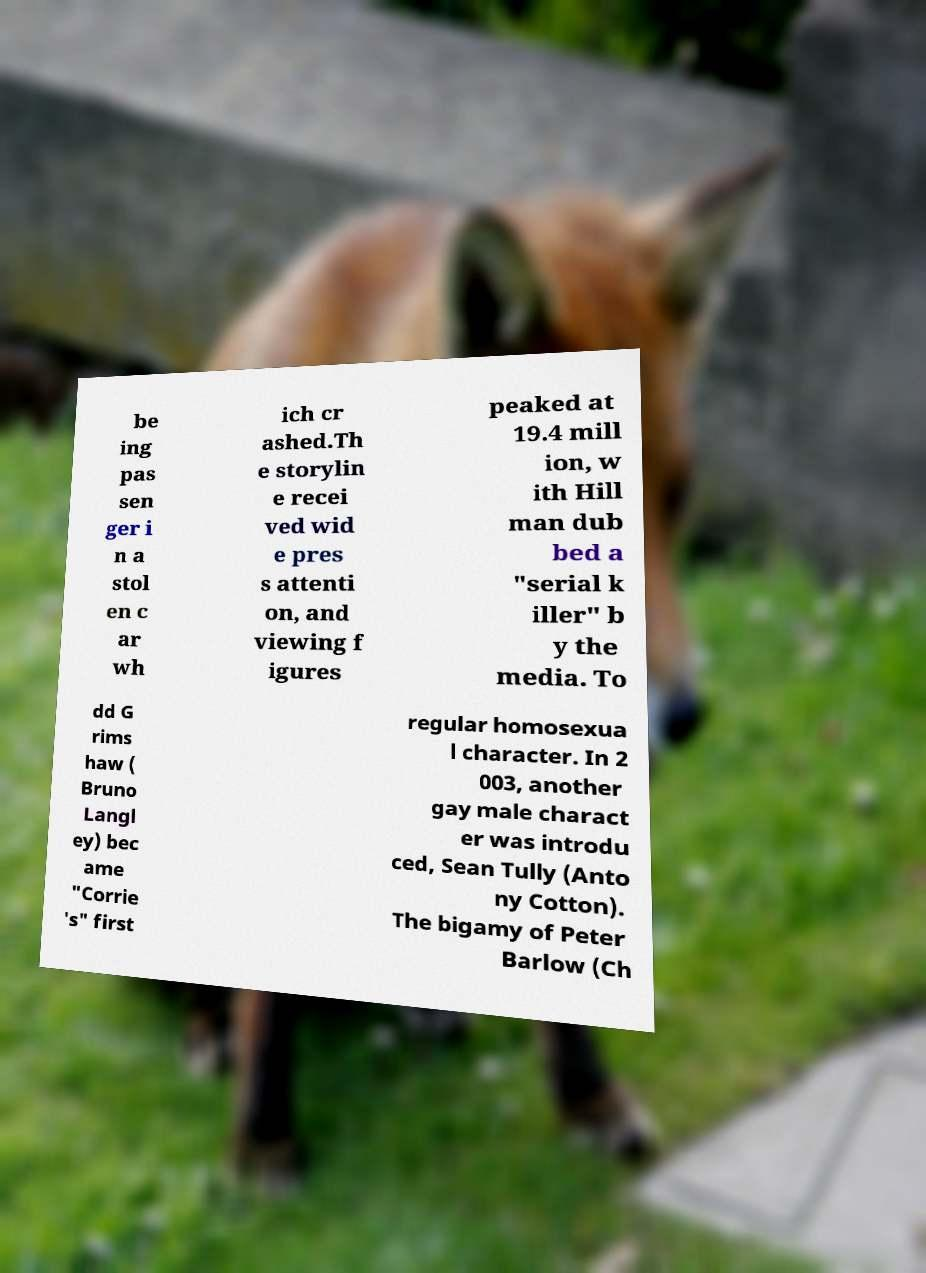For documentation purposes, I need the text within this image transcribed. Could you provide that? be ing pas sen ger i n a stol en c ar wh ich cr ashed.Th e storylin e recei ved wid e pres s attenti on, and viewing f igures peaked at 19.4 mill ion, w ith Hill man dub bed a "serial k iller" b y the media. To dd G rims haw ( Bruno Langl ey) bec ame "Corrie 's" first regular homosexua l character. In 2 003, another gay male charact er was introdu ced, Sean Tully (Anto ny Cotton). The bigamy of Peter Barlow (Ch 